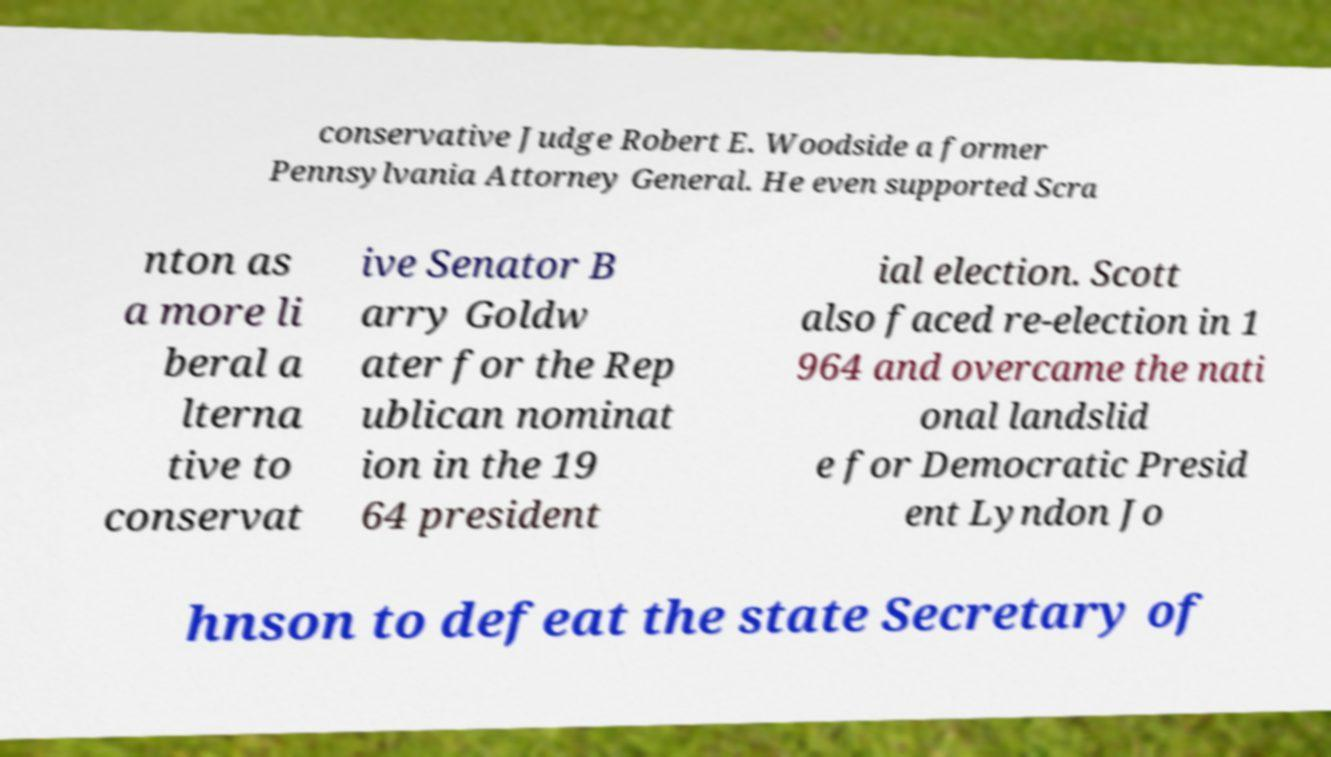Please identify and transcribe the text found in this image. conservative Judge Robert E. Woodside a former Pennsylvania Attorney General. He even supported Scra nton as a more li beral a lterna tive to conservat ive Senator B arry Goldw ater for the Rep ublican nominat ion in the 19 64 president ial election. Scott also faced re-election in 1 964 and overcame the nati onal landslid e for Democratic Presid ent Lyndon Jo hnson to defeat the state Secretary of 